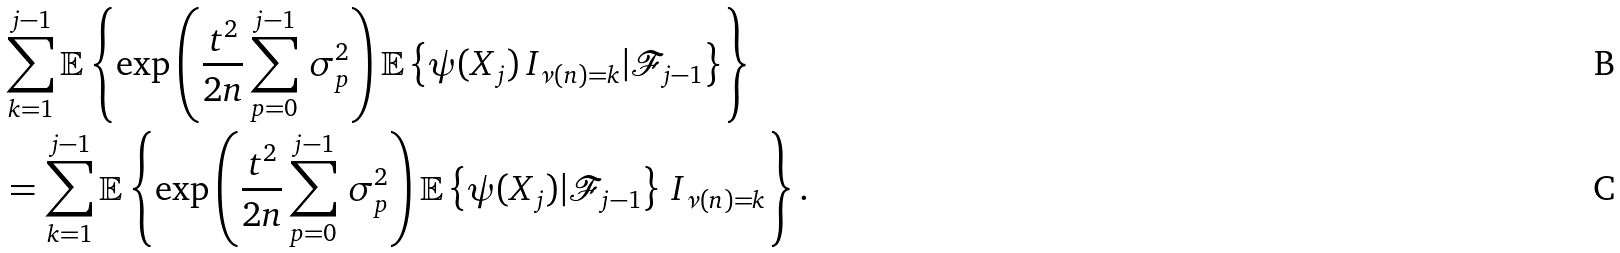Convert formula to latex. <formula><loc_0><loc_0><loc_500><loc_500>& \sum _ { k = 1 } ^ { j - 1 } \mathbb { E } \left \{ \exp \left ( \frac { t ^ { 2 } } { 2 n } \sum _ { p = 0 } ^ { j - 1 } \, \sigma _ { p } ^ { 2 } \right ) \mathbb { E } \left \{ \psi ( X _ { j } ) \, I _ { \nu ( n ) = k } | \mathcal { F } _ { j - 1 } \right \} \right \} \\ & = \sum _ { k = 1 } ^ { j - 1 } \mathbb { E } \left \{ \exp \left ( \frac { t ^ { 2 } } { 2 n } \sum _ { p = 0 } ^ { j - 1 } \, \sigma _ { p } ^ { 2 } \right ) \mathbb { E } \left \{ \psi ( X _ { j } ) | \mathcal { F } _ { j - 1 } \right \} \, I _ { \nu ( n ) = k } \right \} .</formula> 